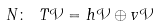Convert formula to latex. <formula><loc_0><loc_0><loc_500><loc_500>N \colon \ T \mathcal { V } = h \mathcal { V } \oplus v \mathcal { V }</formula> 